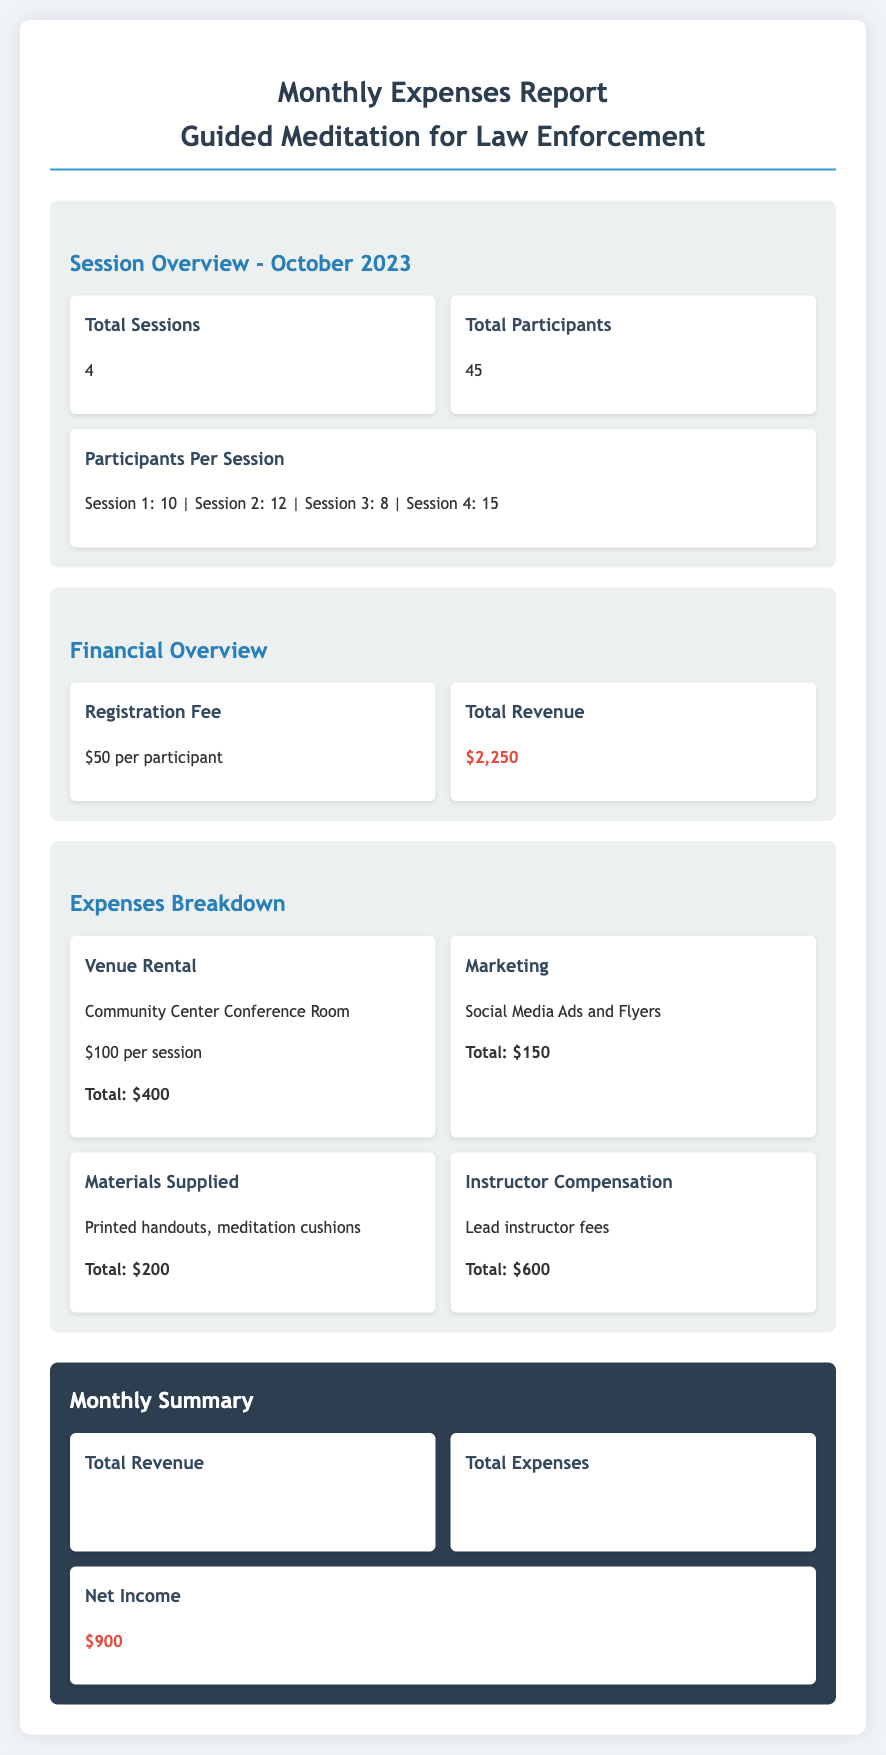What is the total number of sessions? The document states that there were a total of 4 sessions conducted in October 2023.
Answer: 4 What was the registration fee per participant? According to the financial overview, the registration fee for each participant was $50.
Answer: $50 How many participants attended the sessions? The total number of participants across all sessions is reported as 45 in the document.
Answer: 45 What is the total amount spent on venue rental? The expenses breakdown lists the total venue rental cost as $400 for four sessions at $100 each.
Answer: $400 What was the total revenue generated? The total revenue is summarized in the document as $2,250.
Answer: $2,250 What are the total expenses listed in the document? Total expenses are reported as the sum of all expense categories, amounting to $1,350.
Answer: $1,350 What is the net income for the month? The document states that the net income after subtracting expenses from revenue is $900.
Answer: $900 How much was spent on instructor compensation? The expenses for instructor compensation are detailed as totaling $600.
Answer: $600 What materials were supplied for the sessions? The materials supplied included printed handouts and meditation cushions, as indicated in the expenses breakdown.
Answer: Printed handouts, meditation cushions 